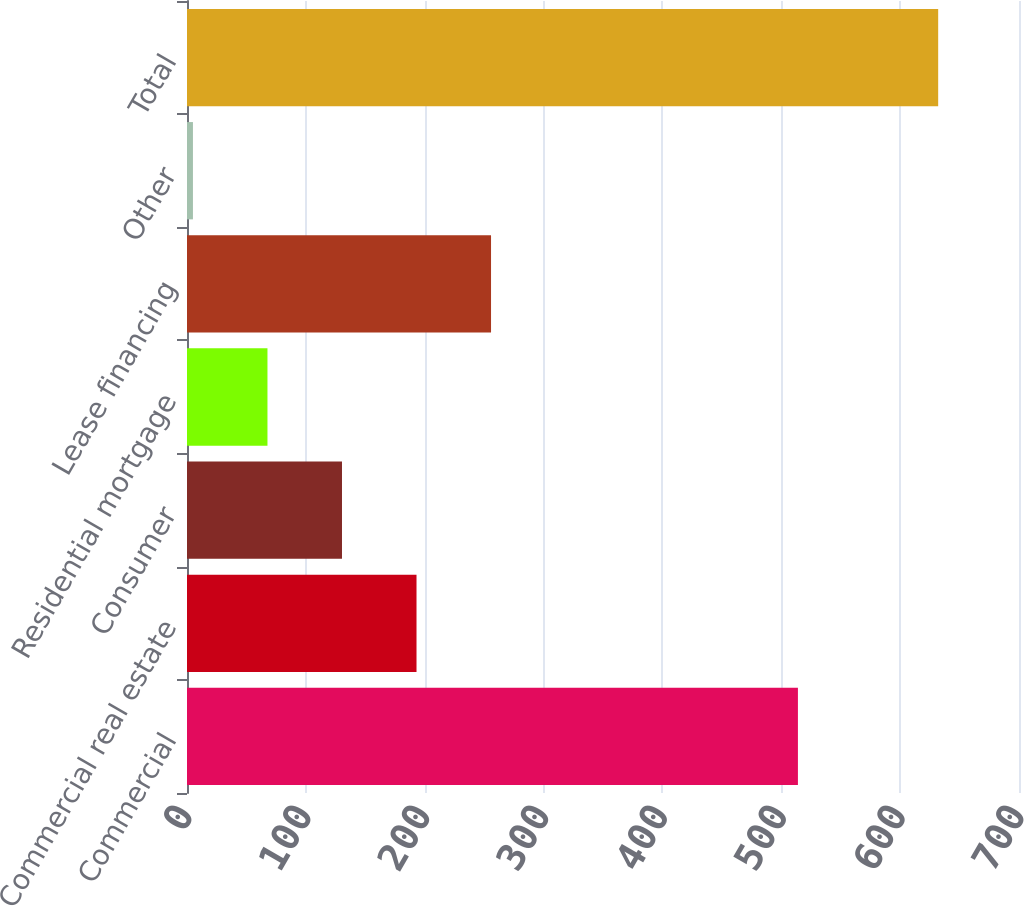<chart> <loc_0><loc_0><loc_500><loc_500><bar_chart><fcel>Commercial<fcel>Commercial real estate<fcel>Consumer<fcel>Residential mortgage<fcel>Lease financing<fcel>Other<fcel>Total<nl><fcel>514<fcel>193.1<fcel>130.4<fcel>67.7<fcel>255.8<fcel>5<fcel>632<nl></chart> 